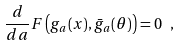Convert formula to latex. <formula><loc_0><loc_0><loc_500><loc_500>\frac { d } { d a } F \left ( g _ { a } ( x ) , \bar { g } _ { a } ( \theta ) \right ) = 0 \ ,</formula> 